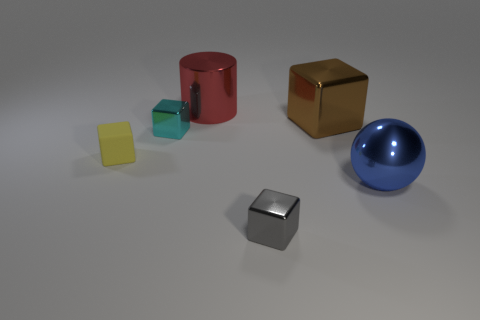Subtract all big blocks. How many blocks are left? 3 Subtract all yellow cubes. How many cubes are left? 3 Subtract all purple blocks. Subtract all red cylinders. How many blocks are left? 4 Add 3 cyan metal cylinders. How many objects exist? 9 Subtract all blocks. How many objects are left? 2 Add 4 yellow matte objects. How many yellow matte objects exist? 5 Subtract 0 red blocks. How many objects are left? 6 Subtract all tiny gray objects. Subtract all small cyan blocks. How many objects are left? 4 Add 3 cyan metallic things. How many cyan metallic things are left? 4 